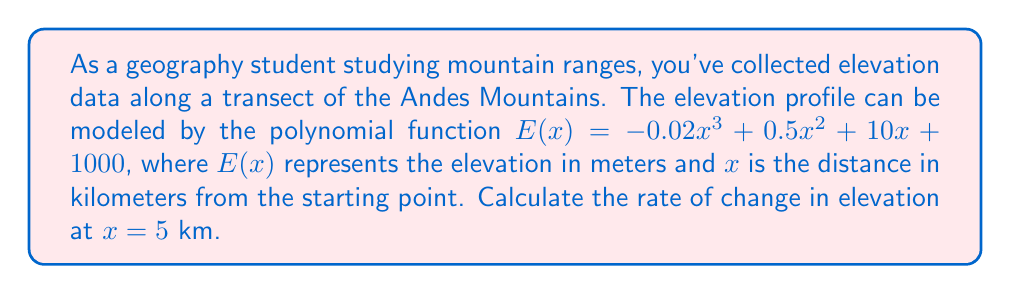Help me with this question. To solve this problem, we need to find the derivative of the elevation function and evaluate it at the given point. The derivative represents the rate of change of the function.

1. Given elevation function: 
   $E(x) = -0.02x^3 + 0.5x^2 + 10x + 1000$

2. Find the derivative $E'(x)$:
   $E'(x) = \frac{d}{dx}(-0.02x^3 + 0.5x^2 + 10x + 1000)$
   $E'(x) = -0.06x^2 + x + 10$

3. Evaluate $E'(x)$ at $x = 5$:
   $E'(5) = -0.06(5)^2 + 5 + 10$
   $E'(5) = -0.06(25) + 5 + 10$
   $E'(5) = -1.5 + 5 + 10$
   $E'(5) = 13.5$

The rate of change at $x = 5$ km is 13.5 m/km, indicating that the elevation is increasing at this point.
Answer: The rate of change in elevation at $x = 5$ km is 13.5 m/km. 